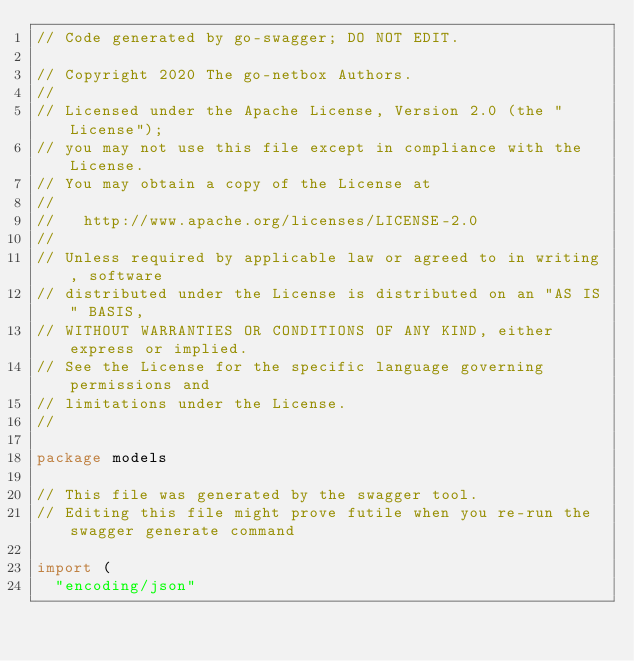<code> <loc_0><loc_0><loc_500><loc_500><_Go_>// Code generated by go-swagger; DO NOT EDIT.

// Copyright 2020 The go-netbox Authors.
//
// Licensed under the Apache License, Version 2.0 (the "License");
// you may not use this file except in compliance with the License.
// You may obtain a copy of the License at
//
//   http://www.apache.org/licenses/LICENSE-2.0
//
// Unless required by applicable law or agreed to in writing, software
// distributed under the License is distributed on an "AS IS" BASIS,
// WITHOUT WARRANTIES OR CONDITIONS OF ANY KIND, either express or implied.
// See the License for the specific language governing permissions and
// limitations under the License.
//

package models

// This file was generated by the swagger tool.
// Editing this file might prove futile when you re-run the swagger generate command

import (
	"encoding/json"</code> 